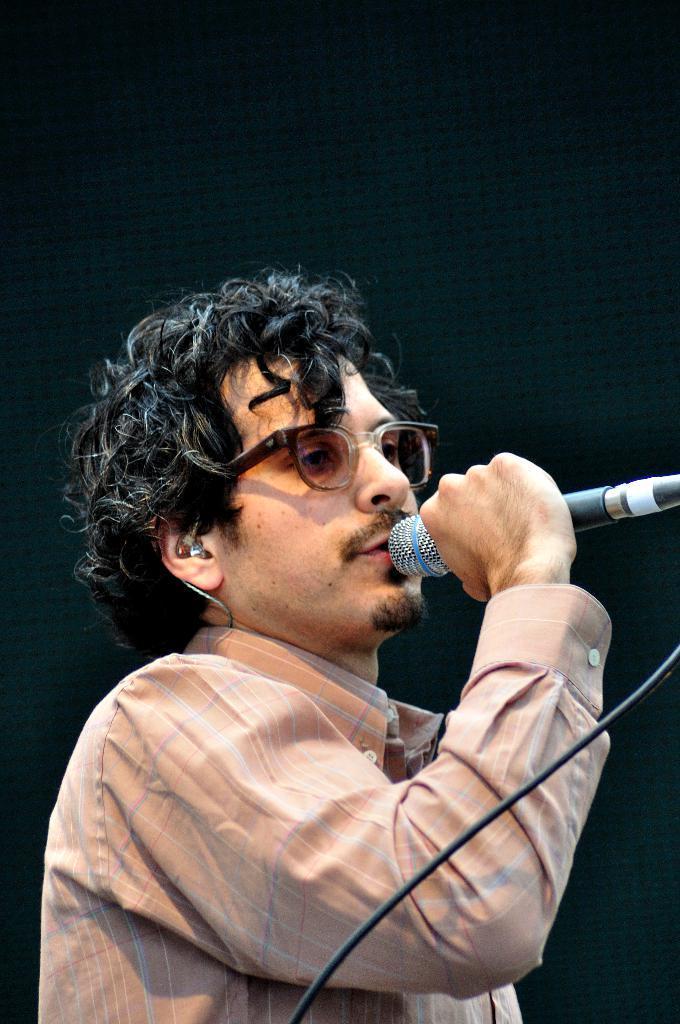In one or two sentences, can you explain what this image depicts? This image consists of a man wearing a cream color shirt. He is holding a mic. The background is black in color. It looks like he is singing. 